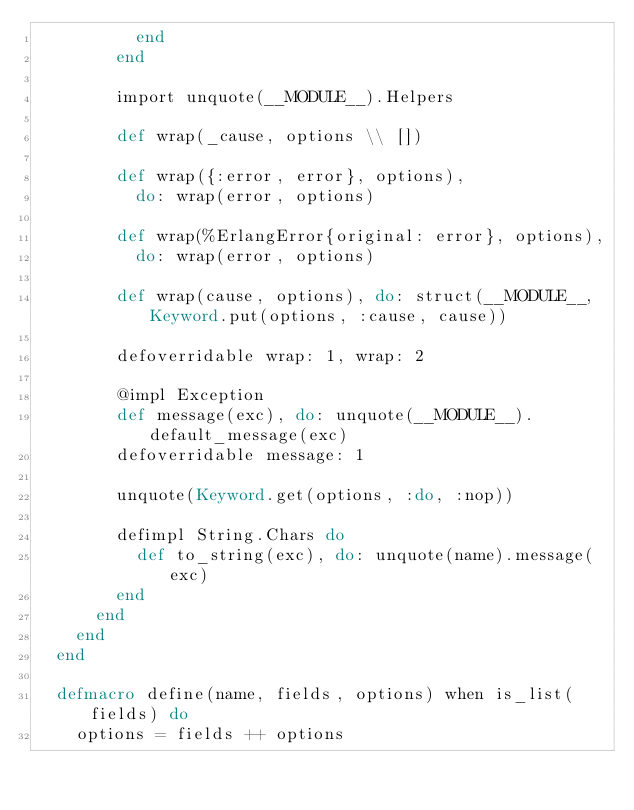Convert code to text. <code><loc_0><loc_0><loc_500><loc_500><_Elixir_>          end
        end

        import unquote(__MODULE__).Helpers

        def wrap(_cause, options \\ [])

        def wrap({:error, error}, options),
          do: wrap(error, options)

        def wrap(%ErlangError{original: error}, options),
          do: wrap(error, options)

        def wrap(cause, options), do: struct(__MODULE__, Keyword.put(options, :cause, cause))

        defoverridable wrap: 1, wrap: 2

        @impl Exception
        def message(exc), do: unquote(__MODULE__).default_message(exc)
        defoverridable message: 1

        unquote(Keyword.get(options, :do, :nop))

        defimpl String.Chars do
          def to_string(exc), do: unquote(name).message(exc)
        end
      end
    end
  end

  defmacro define(name, fields, options) when is_list(fields) do
    options = fields ++ options
</code> 